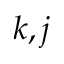Convert formula to latex. <formula><loc_0><loc_0><loc_500><loc_500>k , j</formula> 